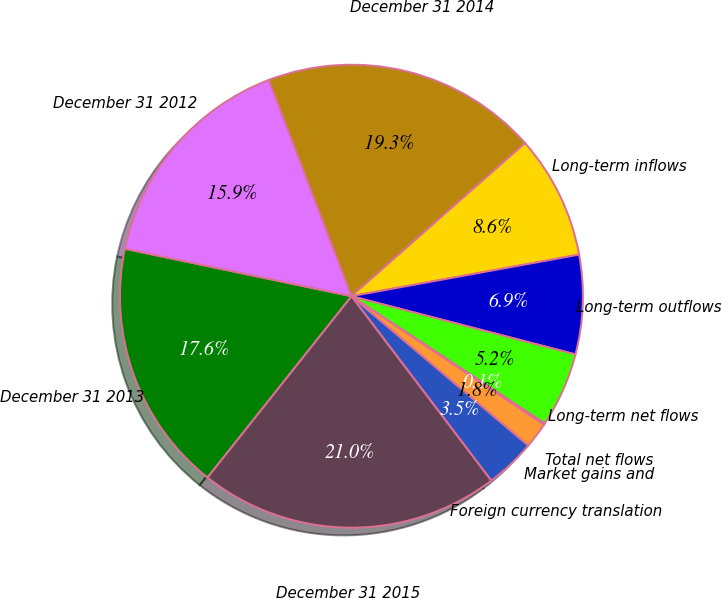<chart> <loc_0><loc_0><loc_500><loc_500><pie_chart><fcel>December 31 2014<fcel>Long-term inflows<fcel>Long-term outflows<fcel>Long-term net flows<fcel>Total net flows<fcel>Market gains and<fcel>Foreign currency translation<fcel>December 31 2015<fcel>December 31 2013<fcel>December 31 2012<nl><fcel>19.31%<fcel>8.63%<fcel>6.92%<fcel>5.22%<fcel>0.1%<fcel>1.8%<fcel>3.51%<fcel>21.01%<fcel>17.6%<fcel>15.9%<nl></chart> 